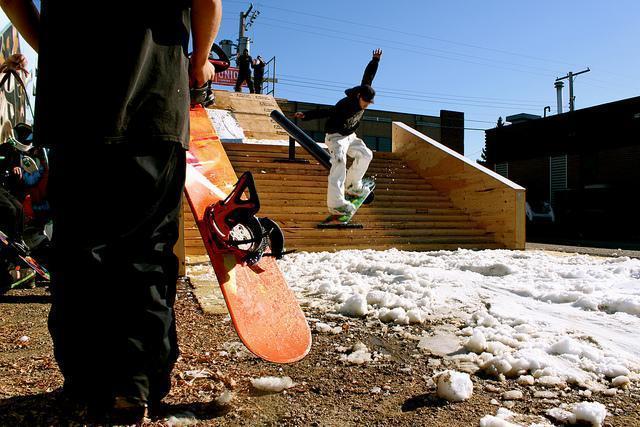How many people are there?
Give a very brief answer. 3. 